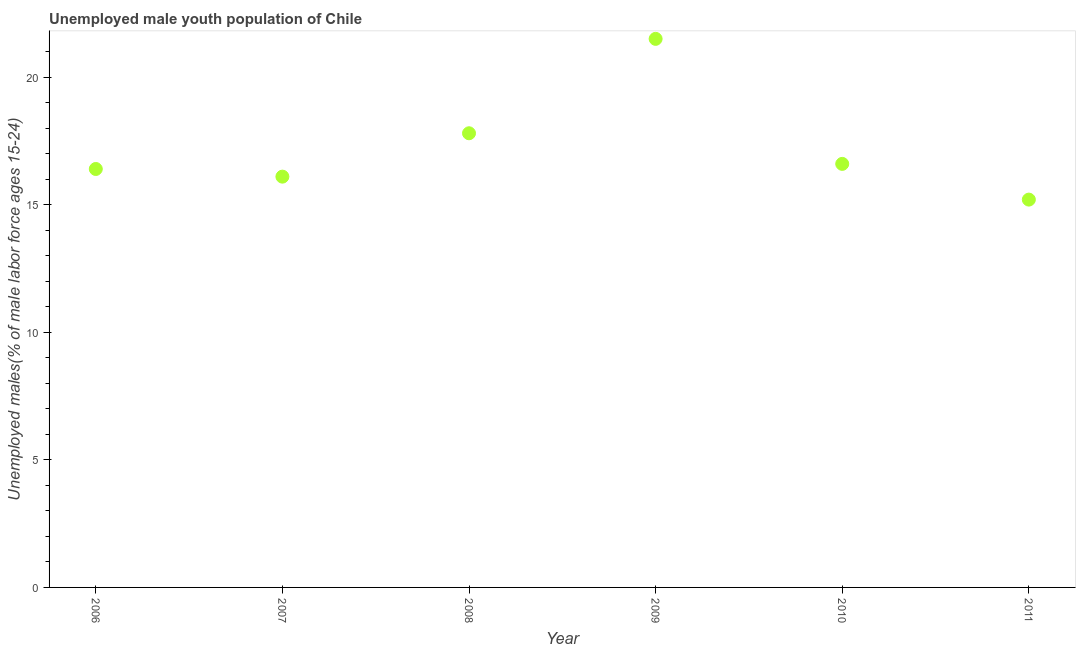What is the unemployed male youth in 2008?
Your answer should be very brief. 17.8. Across all years, what is the maximum unemployed male youth?
Give a very brief answer. 21.5. Across all years, what is the minimum unemployed male youth?
Your answer should be compact. 15.2. In which year was the unemployed male youth maximum?
Keep it short and to the point. 2009. What is the sum of the unemployed male youth?
Offer a very short reply. 103.6. What is the difference between the unemployed male youth in 2006 and 2008?
Provide a short and direct response. -1.4. What is the average unemployed male youth per year?
Your answer should be very brief. 17.27. Do a majority of the years between 2009 and 2006 (inclusive) have unemployed male youth greater than 4 %?
Your answer should be very brief. Yes. What is the ratio of the unemployed male youth in 2006 to that in 2007?
Offer a terse response. 1.02. Is the unemployed male youth in 2009 less than that in 2011?
Offer a very short reply. No. Is the difference between the unemployed male youth in 2006 and 2008 greater than the difference between any two years?
Your answer should be very brief. No. What is the difference between the highest and the second highest unemployed male youth?
Your answer should be compact. 3.7. Is the sum of the unemployed male youth in 2007 and 2009 greater than the maximum unemployed male youth across all years?
Provide a short and direct response. Yes. What is the difference between the highest and the lowest unemployed male youth?
Your answer should be very brief. 6.3. In how many years, is the unemployed male youth greater than the average unemployed male youth taken over all years?
Provide a short and direct response. 2. How many dotlines are there?
Ensure brevity in your answer.  1. How many years are there in the graph?
Keep it short and to the point. 6. Are the values on the major ticks of Y-axis written in scientific E-notation?
Provide a succinct answer. No. Does the graph contain any zero values?
Ensure brevity in your answer.  No. Does the graph contain grids?
Provide a short and direct response. No. What is the title of the graph?
Your response must be concise. Unemployed male youth population of Chile. What is the label or title of the Y-axis?
Offer a terse response. Unemployed males(% of male labor force ages 15-24). What is the Unemployed males(% of male labor force ages 15-24) in 2006?
Your response must be concise. 16.4. What is the Unemployed males(% of male labor force ages 15-24) in 2007?
Make the answer very short. 16.1. What is the Unemployed males(% of male labor force ages 15-24) in 2008?
Your answer should be very brief. 17.8. What is the Unemployed males(% of male labor force ages 15-24) in 2010?
Keep it short and to the point. 16.6. What is the Unemployed males(% of male labor force ages 15-24) in 2011?
Provide a short and direct response. 15.2. What is the difference between the Unemployed males(% of male labor force ages 15-24) in 2006 and 2008?
Provide a succinct answer. -1.4. What is the difference between the Unemployed males(% of male labor force ages 15-24) in 2006 and 2009?
Give a very brief answer. -5.1. What is the difference between the Unemployed males(% of male labor force ages 15-24) in 2006 and 2010?
Ensure brevity in your answer.  -0.2. What is the difference between the Unemployed males(% of male labor force ages 15-24) in 2006 and 2011?
Offer a very short reply. 1.2. What is the difference between the Unemployed males(% of male labor force ages 15-24) in 2007 and 2008?
Your answer should be compact. -1.7. What is the difference between the Unemployed males(% of male labor force ages 15-24) in 2007 and 2009?
Your answer should be compact. -5.4. What is the difference between the Unemployed males(% of male labor force ages 15-24) in 2007 and 2010?
Offer a terse response. -0.5. What is the difference between the Unemployed males(% of male labor force ages 15-24) in 2007 and 2011?
Provide a succinct answer. 0.9. What is the difference between the Unemployed males(% of male labor force ages 15-24) in 2008 and 2009?
Offer a very short reply. -3.7. What is the difference between the Unemployed males(% of male labor force ages 15-24) in 2008 and 2011?
Provide a succinct answer. 2.6. What is the difference between the Unemployed males(% of male labor force ages 15-24) in 2009 and 2010?
Provide a short and direct response. 4.9. What is the difference between the Unemployed males(% of male labor force ages 15-24) in 2010 and 2011?
Ensure brevity in your answer.  1.4. What is the ratio of the Unemployed males(% of male labor force ages 15-24) in 2006 to that in 2008?
Ensure brevity in your answer.  0.92. What is the ratio of the Unemployed males(% of male labor force ages 15-24) in 2006 to that in 2009?
Make the answer very short. 0.76. What is the ratio of the Unemployed males(% of male labor force ages 15-24) in 2006 to that in 2011?
Give a very brief answer. 1.08. What is the ratio of the Unemployed males(% of male labor force ages 15-24) in 2007 to that in 2008?
Your answer should be very brief. 0.9. What is the ratio of the Unemployed males(% of male labor force ages 15-24) in 2007 to that in 2009?
Provide a succinct answer. 0.75. What is the ratio of the Unemployed males(% of male labor force ages 15-24) in 2007 to that in 2010?
Ensure brevity in your answer.  0.97. What is the ratio of the Unemployed males(% of male labor force ages 15-24) in 2007 to that in 2011?
Make the answer very short. 1.06. What is the ratio of the Unemployed males(% of male labor force ages 15-24) in 2008 to that in 2009?
Your answer should be compact. 0.83. What is the ratio of the Unemployed males(% of male labor force ages 15-24) in 2008 to that in 2010?
Offer a very short reply. 1.07. What is the ratio of the Unemployed males(% of male labor force ages 15-24) in 2008 to that in 2011?
Make the answer very short. 1.17. What is the ratio of the Unemployed males(% of male labor force ages 15-24) in 2009 to that in 2010?
Give a very brief answer. 1.29. What is the ratio of the Unemployed males(% of male labor force ages 15-24) in 2009 to that in 2011?
Offer a terse response. 1.41. What is the ratio of the Unemployed males(% of male labor force ages 15-24) in 2010 to that in 2011?
Ensure brevity in your answer.  1.09. 